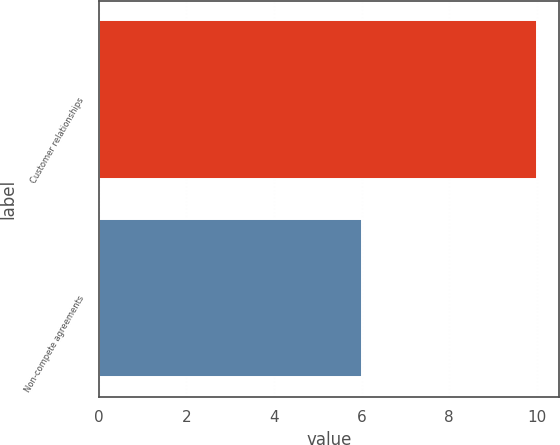Convert chart. <chart><loc_0><loc_0><loc_500><loc_500><bar_chart><fcel>Customer relationships<fcel>Non-compete agreements<nl><fcel>10<fcel>6<nl></chart> 